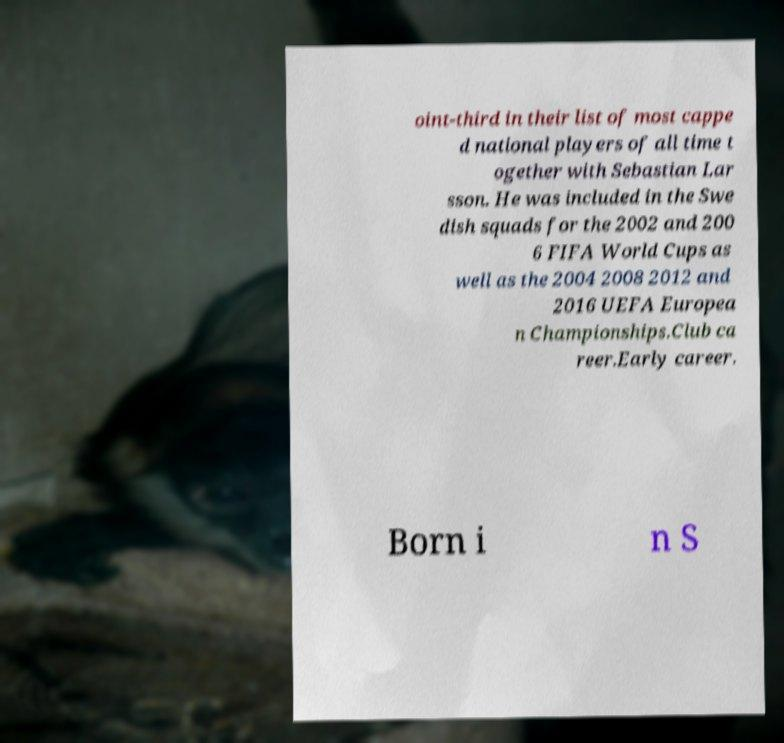For documentation purposes, I need the text within this image transcribed. Could you provide that? oint-third in their list of most cappe d national players of all time t ogether with Sebastian Lar sson. He was included in the Swe dish squads for the 2002 and 200 6 FIFA World Cups as well as the 2004 2008 2012 and 2016 UEFA Europea n Championships.Club ca reer.Early career. Born i n S 